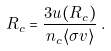Convert formula to latex. <formula><loc_0><loc_0><loc_500><loc_500>R _ { c } = \frac { 3 u ( R _ { c } ) } { n _ { c } \langle \sigma v \rangle } \, .</formula> 